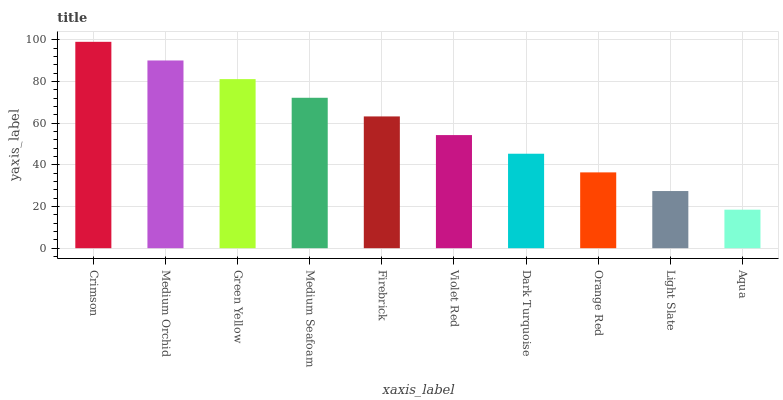Is Aqua the minimum?
Answer yes or no. Yes. Is Crimson the maximum?
Answer yes or no. Yes. Is Medium Orchid the minimum?
Answer yes or no. No. Is Medium Orchid the maximum?
Answer yes or no. No. Is Crimson greater than Medium Orchid?
Answer yes or no. Yes. Is Medium Orchid less than Crimson?
Answer yes or no. Yes. Is Medium Orchid greater than Crimson?
Answer yes or no. No. Is Crimson less than Medium Orchid?
Answer yes or no. No. Is Firebrick the high median?
Answer yes or no. Yes. Is Violet Red the low median?
Answer yes or no. Yes. Is Violet Red the high median?
Answer yes or no. No. Is Light Slate the low median?
Answer yes or no. No. 